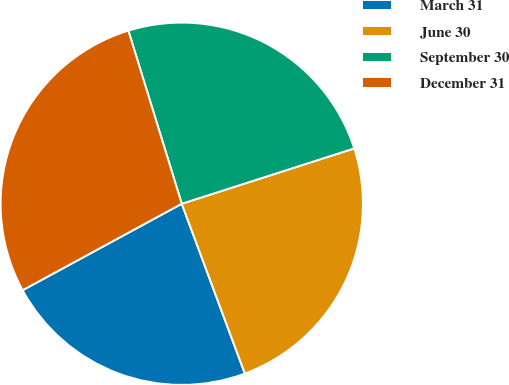Convert chart. <chart><loc_0><loc_0><loc_500><loc_500><pie_chart><fcel>March 31<fcel>June 30<fcel>September 30<fcel>December 31<nl><fcel>22.74%<fcel>24.28%<fcel>24.82%<fcel>28.16%<nl></chart> 